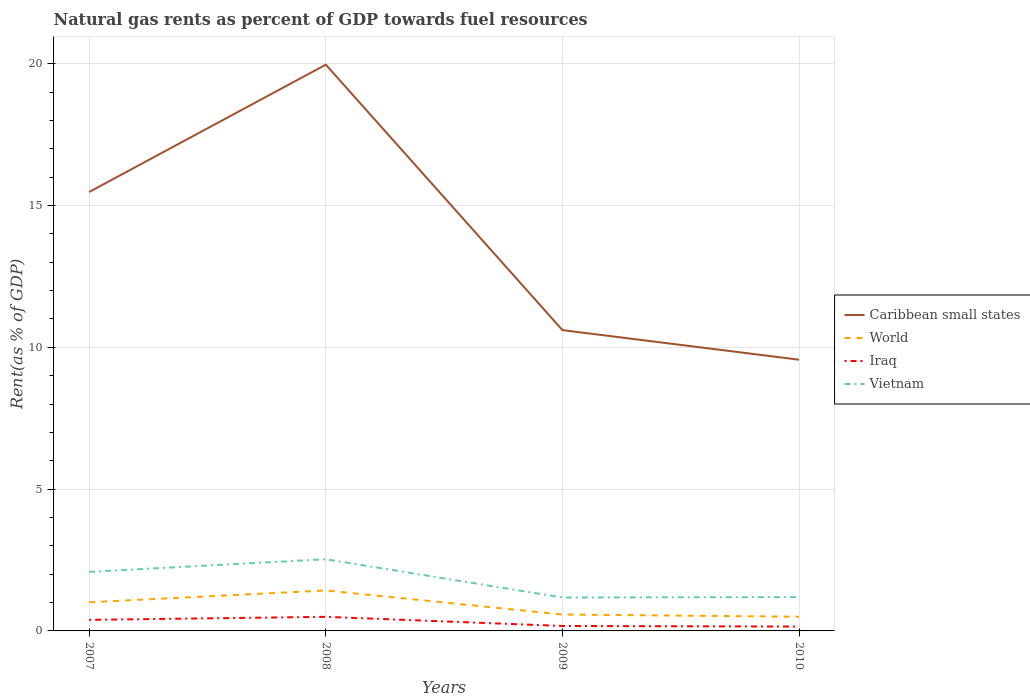How many different coloured lines are there?
Keep it short and to the point. 4. Across all years, what is the maximum matural gas rent in Caribbean small states?
Ensure brevity in your answer.  9.56. What is the total matural gas rent in Vietnam in the graph?
Your answer should be compact. -0.02. What is the difference between the highest and the second highest matural gas rent in World?
Keep it short and to the point. 0.93. What is the difference between the highest and the lowest matural gas rent in Vietnam?
Your answer should be very brief. 2. Is the matural gas rent in Caribbean small states strictly greater than the matural gas rent in World over the years?
Ensure brevity in your answer.  No. How many lines are there?
Give a very brief answer. 4. How many years are there in the graph?
Provide a succinct answer. 4. Does the graph contain any zero values?
Provide a succinct answer. No. Where does the legend appear in the graph?
Ensure brevity in your answer.  Center right. How many legend labels are there?
Ensure brevity in your answer.  4. How are the legend labels stacked?
Provide a succinct answer. Vertical. What is the title of the graph?
Make the answer very short. Natural gas rents as percent of GDP towards fuel resources. What is the label or title of the Y-axis?
Keep it short and to the point. Rent(as % of GDP). What is the Rent(as % of GDP) of Caribbean small states in 2007?
Give a very brief answer. 15.48. What is the Rent(as % of GDP) in World in 2007?
Provide a succinct answer. 1.01. What is the Rent(as % of GDP) of Iraq in 2007?
Offer a very short reply. 0.39. What is the Rent(as % of GDP) in Vietnam in 2007?
Your answer should be very brief. 2.08. What is the Rent(as % of GDP) of Caribbean small states in 2008?
Offer a very short reply. 19.97. What is the Rent(as % of GDP) in World in 2008?
Make the answer very short. 1.43. What is the Rent(as % of GDP) in Iraq in 2008?
Ensure brevity in your answer.  0.5. What is the Rent(as % of GDP) in Vietnam in 2008?
Make the answer very short. 2.53. What is the Rent(as % of GDP) of Caribbean small states in 2009?
Provide a succinct answer. 10.61. What is the Rent(as % of GDP) in World in 2009?
Offer a very short reply. 0.58. What is the Rent(as % of GDP) of Iraq in 2009?
Your answer should be compact. 0.17. What is the Rent(as % of GDP) in Vietnam in 2009?
Your answer should be very brief. 1.18. What is the Rent(as % of GDP) of Caribbean small states in 2010?
Ensure brevity in your answer.  9.56. What is the Rent(as % of GDP) in World in 2010?
Your answer should be very brief. 0.5. What is the Rent(as % of GDP) in Iraq in 2010?
Your response must be concise. 0.15. What is the Rent(as % of GDP) in Vietnam in 2010?
Give a very brief answer. 1.19. Across all years, what is the maximum Rent(as % of GDP) of Caribbean small states?
Give a very brief answer. 19.97. Across all years, what is the maximum Rent(as % of GDP) in World?
Your answer should be very brief. 1.43. Across all years, what is the maximum Rent(as % of GDP) of Iraq?
Ensure brevity in your answer.  0.5. Across all years, what is the maximum Rent(as % of GDP) of Vietnam?
Provide a short and direct response. 2.53. Across all years, what is the minimum Rent(as % of GDP) in Caribbean small states?
Keep it short and to the point. 9.56. Across all years, what is the minimum Rent(as % of GDP) in World?
Your answer should be very brief. 0.5. Across all years, what is the minimum Rent(as % of GDP) of Iraq?
Your response must be concise. 0.15. Across all years, what is the minimum Rent(as % of GDP) of Vietnam?
Provide a succinct answer. 1.18. What is the total Rent(as % of GDP) in Caribbean small states in the graph?
Give a very brief answer. 55.61. What is the total Rent(as % of GDP) in World in the graph?
Provide a short and direct response. 3.51. What is the total Rent(as % of GDP) of Iraq in the graph?
Offer a very short reply. 1.22. What is the total Rent(as % of GDP) of Vietnam in the graph?
Provide a succinct answer. 6.98. What is the difference between the Rent(as % of GDP) of Caribbean small states in 2007 and that in 2008?
Offer a terse response. -4.49. What is the difference between the Rent(as % of GDP) of World in 2007 and that in 2008?
Give a very brief answer. -0.42. What is the difference between the Rent(as % of GDP) of Iraq in 2007 and that in 2008?
Give a very brief answer. -0.11. What is the difference between the Rent(as % of GDP) in Vietnam in 2007 and that in 2008?
Offer a very short reply. -0.44. What is the difference between the Rent(as % of GDP) in Caribbean small states in 2007 and that in 2009?
Your response must be concise. 4.87. What is the difference between the Rent(as % of GDP) of World in 2007 and that in 2009?
Offer a terse response. 0.43. What is the difference between the Rent(as % of GDP) of Iraq in 2007 and that in 2009?
Give a very brief answer. 0.22. What is the difference between the Rent(as % of GDP) in Vietnam in 2007 and that in 2009?
Your answer should be very brief. 0.91. What is the difference between the Rent(as % of GDP) of Caribbean small states in 2007 and that in 2010?
Offer a terse response. 5.92. What is the difference between the Rent(as % of GDP) in World in 2007 and that in 2010?
Offer a very short reply. 0.51. What is the difference between the Rent(as % of GDP) of Iraq in 2007 and that in 2010?
Offer a very short reply. 0.24. What is the difference between the Rent(as % of GDP) of Vietnam in 2007 and that in 2010?
Give a very brief answer. 0.89. What is the difference between the Rent(as % of GDP) in Caribbean small states in 2008 and that in 2009?
Make the answer very short. 9.36. What is the difference between the Rent(as % of GDP) of World in 2008 and that in 2009?
Make the answer very short. 0.85. What is the difference between the Rent(as % of GDP) of Iraq in 2008 and that in 2009?
Provide a succinct answer. 0.32. What is the difference between the Rent(as % of GDP) of Vietnam in 2008 and that in 2009?
Provide a succinct answer. 1.35. What is the difference between the Rent(as % of GDP) in Caribbean small states in 2008 and that in 2010?
Offer a very short reply. 10.4. What is the difference between the Rent(as % of GDP) in World in 2008 and that in 2010?
Offer a terse response. 0.93. What is the difference between the Rent(as % of GDP) in Iraq in 2008 and that in 2010?
Provide a short and direct response. 0.34. What is the difference between the Rent(as % of GDP) of Vietnam in 2008 and that in 2010?
Your answer should be compact. 1.33. What is the difference between the Rent(as % of GDP) in Caribbean small states in 2009 and that in 2010?
Offer a terse response. 1.04. What is the difference between the Rent(as % of GDP) in World in 2009 and that in 2010?
Your answer should be compact. 0.08. What is the difference between the Rent(as % of GDP) in Iraq in 2009 and that in 2010?
Ensure brevity in your answer.  0.02. What is the difference between the Rent(as % of GDP) of Vietnam in 2009 and that in 2010?
Provide a succinct answer. -0.02. What is the difference between the Rent(as % of GDP) of Caribbean small states in 2007 and the Rent(as % of GDP) of World in 2008?
Provide a short and direct response. 14.05. What is the difference between the Rent(as % of GDP) of Caribbean small states in 2007 and the Rent(as % of GDP) of Iraq in 2008?
Your answer should be very brief. 14.98. What is the difference between the Rent(as % of GDP) of Caribbean small states in 2007 and the Rent(as % of GDP) of Vietnam in 2008?
Your answer should be compact. 12.95. What is the difference between the Rent(as % of GDP) in World in 2007 and the Rent(as % of GDP) in Iraq in 2008?
Offer a very short reply. 0.51. What is the difference between the Rent(as % of GDP) in World in 2007 and the Rent(as % of GDP) in Vietnam in 2008?
Your answer should be compact. -1.52. What is the difference between the Rent(as % of GDP) in Iraq in 2007 and the Rent(as % of GDP) in Vietnam in 2008?
Provide a short and direct response. -2.14. What is the difference between the Rent(as % of GDP) of Caribbean small states in 2007 and the Rent(as % of GDP) of World in 2009?
Provide a short and direct response. 14.9. What is the difference between the Rent(as % of GDP) in Caribbean small states in 2007 and the Rent(as % of GDP) in Iraq in 2009?
Offer a terse response. 15.3. What is the difference between the Rent(as % of GDP) in Caribbean small states in 2007 and the Rent(as % of GDP) in Vietnam in 2009?
Offer a terse response. 14.3. What is the difference between the Rent(as % of GDP) of World in 2007 and the Rent(as % of GDP) of Iraq in 2009?
Offer a very short reply. 0.84. What is the difference between the Rent(as % of GDP) in World in 2007 and the Rent(as % of GDP) in Vietnam in 2009?
Provide a short and direct response. -0.17. What is the difference between the Rent(as % of GDP) of Iraq in 2007 and the Rent(as % of GDP) of Vietnam in 2009?
Your response must be concise. -0.79. What is the difference between the Rent(as % of GDP) of Caribbean small states in 2007 and the Rent(as % of GDP) of World in 2010?
Offer a very short reply. 14.98. What is the difference between the Rent(as % of GDP) in Caribbean small states in 2007 and the Rent(as % of GDP) in Iraq in 2010?
Offer a very short reply. 15.32. What is the difference between the Rent(as % of GDP) in Caribbean small states in 2007 and the Rent(as % of GDP) in Vietnam in 2010?
Offer a very short reply. 14.28. What is the difference between the Rent(as % of GDP) in World in 2007 and the Rent(as % of GDP) in Iraq in 2010?
Your answer should be compact. 0.86. What is the difference between the Rent(as % of GDP) of World in 2007 and the Rent(as % of GDP) of Vietnam in 2010?
Your answer should be very brief. -0.18. What is the difference between the Rent(as % of GDP) in Iraq in 2007 and the Rent(as % of GDP) in Vietnam in 2010?
Provide a succinct answer. -0.8. What is the difference between the Rent(as % of GDP) in Caribbean small states in 2008 and the Rent(as % of GDP) in World in 2009?
Your answer should be compact. 19.39. What is the difference between the Rent(as % of GDP) of Caribbean small states in 2008 and the Rent(as % of GDP) of Iraq in 2009?
Offer a very short reply. 19.79. What is the difference between the Rent(as % of GDP) in Caribbean small states in 2008 and the Rent(as % of GDP) in Vietnam in 2009?
Make the answer very short. 18.79. What is the difference between the Rent(as % of GDP) of World in 2008 and the Rent(as % of GDP) of Iraq in 2009?
Provide a short and direct response. 1.25. What is the difference between the Rent(as % of GDP) of World in 2008 and the Rent(as % of GDP) of Vietnam in 2009?
Ensure brevity in your answer.  0.25. What is the difference between the Rent(as % of GDP) in Iraq in 2008 and the Rent(as % of GDP) in Vietnam in 2009?
Your answer should be very brief. -0.68. What is the difference between the Rent(as % of GDP) in Caribbean small states in 2008 and the Rent(as % of GDP) in World in 2010?
Provide a short and direct response. 19.47. What is the difference between the Rent(as % of GDP) of Caribbean small states in 2008 and the Rent(as % of GDP) of Iraq in 2010?
Your answer should be compact. 19.81. What is the difference between the Rent(as % of GDP) in Caribbean small states in 2008 and the Rent(as % of GDP) in Vietnam in 2010?
Ensure brevity in your answer.  18.77. What is the difference between the Rent(as % of GDP) of World in 2008 and the Rent(as % of GDP) of Iraq in 2010?
Give a very brief answer. 1.27. What is the difference between the Rent(as % of GDP) of World in 2008 and the Rent(as % of GDP) of Vietnam in 2010?
Provide a succinct answer. 0.23. What is the difference between the Rent(as % of GDP) of Iraq in 2008 and the Rent(as % of GDP) of Vietnam in 2010?
Offer a very short reply. -0.7. What is the difference between the Rent(as % of GDP) in Caribbean small states in 2009 and the Rent(as % of GDP) in World in 2010?
Your response must be concise. 10.11. What is the difference between the Rent(as % of GDP) of Caribbean small states in 2009 and the Rent(as % of GDP) of Iraq in 2010?
Keep it short and to the point. 10.45. What is the difference between the Rent(as % of GDP) of Caribbean small states in 2009 and the Rent(as % of GDP) of Vietnam in 2010?
Make the answer very short. 9.41. What is the difference between the Rent(as % of GDP) of World in 2009 and the Rent(as % of GDP) of Iraq in 2010?
Your answer should be very brief. 0.43. What is the difference between the Rent(as % of GDP) of World in 2009 and the Rent(as % of GDP) of Vietnam in 2010?
Your answer should be very brief. -0.61. What is the difference between the Rent(as % of GDP) in Iraq in 2009 and the Rent(as % of GDP) in Vietnam in 2010?
Your answer should be compact. -1.02. What is the average Rent(as % of GDP) of Caribbean small states per year?
Provide a short and direct response. 13.9. What is the average Rent(as % of GDP) in World per year?
Ensure brevity in your answer.  0.88. What is the average Rent(as % of GDP) of Iraq per year?
Offer a terse response. 0.3. What is the average Rent(as % of GDP) in Vietnam per year?
Your answer should be compact. 1.75. In the year 2007, what is the difference between the Rent(as % of GDP) in Caribbean small states and Rent(as % of GDP) in World?
Provide a succinct answer. 14.47. In the year 2007, what is the difference between the Rent(as % of GDP) in Caribbean small states and Rent(as % of GDP) in Iraq?
Ensure brevity in your answer.  15.09. In the year 2007, what is the difference between the Rent(as % of GDP) of Caribbean small states and Rent(as % of GDP) of Vietnam?
Offer a terse response. 13.39. In the year 2007, what is the difference between the Rent(as % of GDP) in World and Rent(as % of GDP) in Iraq?
Your response must be concise. 0.62. In the year 2007, what is the difference between the Rent(as % of GDP) of World and Rent(as % of GDP) of Vietnam?
Offer a very short reply. -1.07. In the year 2007, what is the difference between the Rent(as % of GDP) in Iraq and Rent(as % of GDP) in Vietnam?
Give a very brief answer. -1.69. In the year 2008, what is the difference between the Rent(as % of GDP) in Caribbean small states and Rent(as % of GDP) in World?
Provide a short and direct response. 18.54. In the year 2008, what is the difference between the Rent(as % of GDP) of Caribbean small states and Rent(as % of GDP) of Iraq?
Keep it short and to the point. 19.47. In the year 2008, what is the difference between the Rent(as % of GDP) in Caribbean small states and Rent(as % of GDP) in Vietnam?
Offer a very short reply. 17.44. In the year 2008, what is the difference between the Rent(as % of GDP) of World and Rent(as % of GDP) of Iraq?
Your answer should be very brief. 0.93. In the year 2008, what is the difference between the Rent(as % of GDP) of World and Rent(as % of GDP) of Vietnam?
Offer a very short reply. -1.1. In the year 2008, what is the difference between the Rent(as % of GDP) in Iraq and Rent(as % of GDP) in Vietnam?
Give a very brief answer. -2.03. In the year 2009, what is the difference between the Rent(as % of GDP) of Caribbean small states and Rent(as % of GDP) of World?
Keep it short and to the point. 10.03. In the year 2009, what is the difference between the Rent(as % of GDP) of Caribbean small states and Rent(as % of GDP) of Iraq?
Offer a terse response. 10.43. In the year 2009, what is the difference between the Rent(as % of GDP) of Caribbean small states and Rent(as % of GDP) of Vietnam?
Offer a very short reply. 9.43. In the year 2009, what is the difference between the Rent(as % of GDP) of World and Rent(as % of GDP) of Iraq?
Your answer should be very brief. 0.4. In the year 2009, what is the difference between the Rent(as % of GDP) in World and Rent(as % of GDP) in Vietnam?
Keep it short and to the point. -0.6. In the year 2009, what is the difference between the Rent(as % of GDP) in Iraq and Rent(as % of GDP) in Vietnam?
Provide a short and direct response. -1. In the year 2010, what is the difference between the Rent(as % of GDP) in Caribbean small states and Rent(as % of GDP) in World?
Keep it short and to the point. 9.06. In the year 2010, what is the difference between the Rent(as % of GDP) of Caribbean small states and Rent(as % of GDP) of Iraq?
Your answer should be very brief. 9.41. In the year 2010, what is the difference between the Rent(as % of GDP) of Caribbean small states and Rent(as % of GDP) of Vietnam?
Make the answer very short. 8.37. In the year 2010, what is the difference between the Rent(as % of GDP) of World and Rent(as % of GDP) of Iraq?
Provide a succinct answer. 0.35. In the year 2010, what is the difference between the Rent(as % of GDP) of World and Rent(as % of GDP) of Vietnam?
Provide a short and direct response. -0.69. In the year 2010, what is the difference between the Rent(as % of GDP) in Iraq and Rent(as % of GDP) in Vietnam?
Make the answer very short. -1.04. What is the ratio of the Rent(as % of GDP) in Caribbean small states in 2007 to that in 2008?
Offer a terse response. 0.78. What is the ratio of the Rent(as % of GDP) of World in 2007 to that in 2008?
Keep it short and to the point. 0.71. What is the ratio of the Rent(as % of GDP) of Iraq in 2007 to that in 2008?
Keep it short and to the point. 0.79. What is the ratio of the Rent(as % of GDP) in Vietnam in 2007 to that in 2008?
Provide a short and direct response. 0.82. What is the ratio of the Rent(as % of GDP) of Caribbean small states in 2007 to that in 2009?
Give a very brief answer. 1.46. What is the ratio of the Rent(as % of GDP) in World in 2007 to that in 2009?
Your answer should be compact. 1.75. What is the ratio of the Rent(as % of GDP) in Iraq in 2007 to that in 2009?
Provide a short and direct response. 2.23. What is the ratio of the Rent(as % of GDP) in Vietnam in 2007 to that in 2009?
Ensure brevity in your answer.  1.77. What is the ratio of the Rent(as % of GDP) in Caribbean small states in 2007 to that in 2010?
Ensure brevity in your answer.  1.62. What is the ratio of the Rent(as % of GDP) in World in 2007 to that in 2010?
Provide a short and direct response. 2.02. What is the ratio of the Rent(as % of GDP) in Iraq in 2007 to that in 2010?
Give a very brief answer. 2.55. What is the ratio of the Rent(as % of GDP) of Vietnam in 2007 to that in 2010?
Your answer should be very brief. 1.75. What is the ratio of the Rent(as % of GDP) of Caribbean small states in 2008 to that in 2009?
Give a very brief answer. 1.88. What is the ratio of the Rent(as % of GDP) in World in 2008 to that in 2009?
Make the answer very short. 2.46. What is the ratio of the Rent(as % of GDP) in Iraq in 2008 to that in 2009?
Your response must be concise. 2.84. What is the ratio of the Rent(as % of GDP) in Vietnam in 2008 to that in 2009?
Give a very brief answer. 2.15. What is the ratio of the Rent(as % of GDP) of Caribbean small states in 2008 to that in 2010?
Provide a succinct answer. 2.09. What is the ratio of the Rent(as % of GDP) in World in 2008 to that in 2010?
Your response must be concise. 2.86. What is the ratio of the Rent(as % of GDP) in Iraq in 2008 to that in 2010?
Your answer should be compact. 3.24. What is the ratio of the Rent(as % of GDP) of Vietnam in 2008 to that in 2010?
Keep it short and to the point. 2.12. What is the ratio of the Rent(as % of GDP) of Caribbean small states in 2009 to that in 2010?
Keep it short and to the point. 1.11. What is the ratio of the Rent(as % of GDP) in World in 2009 to that in 2010?
Offer a terse response. 1.16. What is the ratio of the Rent(as % of GDP) in Iraq in 2009 to that in 2010?
Give a very brief answer. 1.14. What is the ratio of the Rent(as % of GDP) of Vietnam in 2009 to that in 2010?
Offer a very short reply. 0.99. What is the difference between the highest and the second highest Rent(as % of GDP) in Caribbean small states?
Provide a short and direct response. 4.49. What is the difference between the highest and the second highest Rent(as % of GDP) in World?
Offer a very short reply. 0.42. What is the difference between the highest and the second highest Rent(as % of GDP) in Iraq?
Your answer should be compact. 0.11. What is the difference between the highest and the second highest Rent(as % of GDP) of Vietnam?
Make the answer very short. 0.44. What is the difference between the highest and the lowest Rent(as % of GDP) of Caribbean small states?
Give a very brief answer. 10.4. What is the difference between the highest and the lowest Rent(as % of GDP) in World?
Your answer should be very brief. 0.93. What is the difference between the highest and the lowest Rent(as % of GDP) of Iraq?
Give a very brief answer. 0.34. What is the difference between the highest and the lowest Rent(as % of GDP) of Vietnam?
Your answer should be compact. 1.35. 